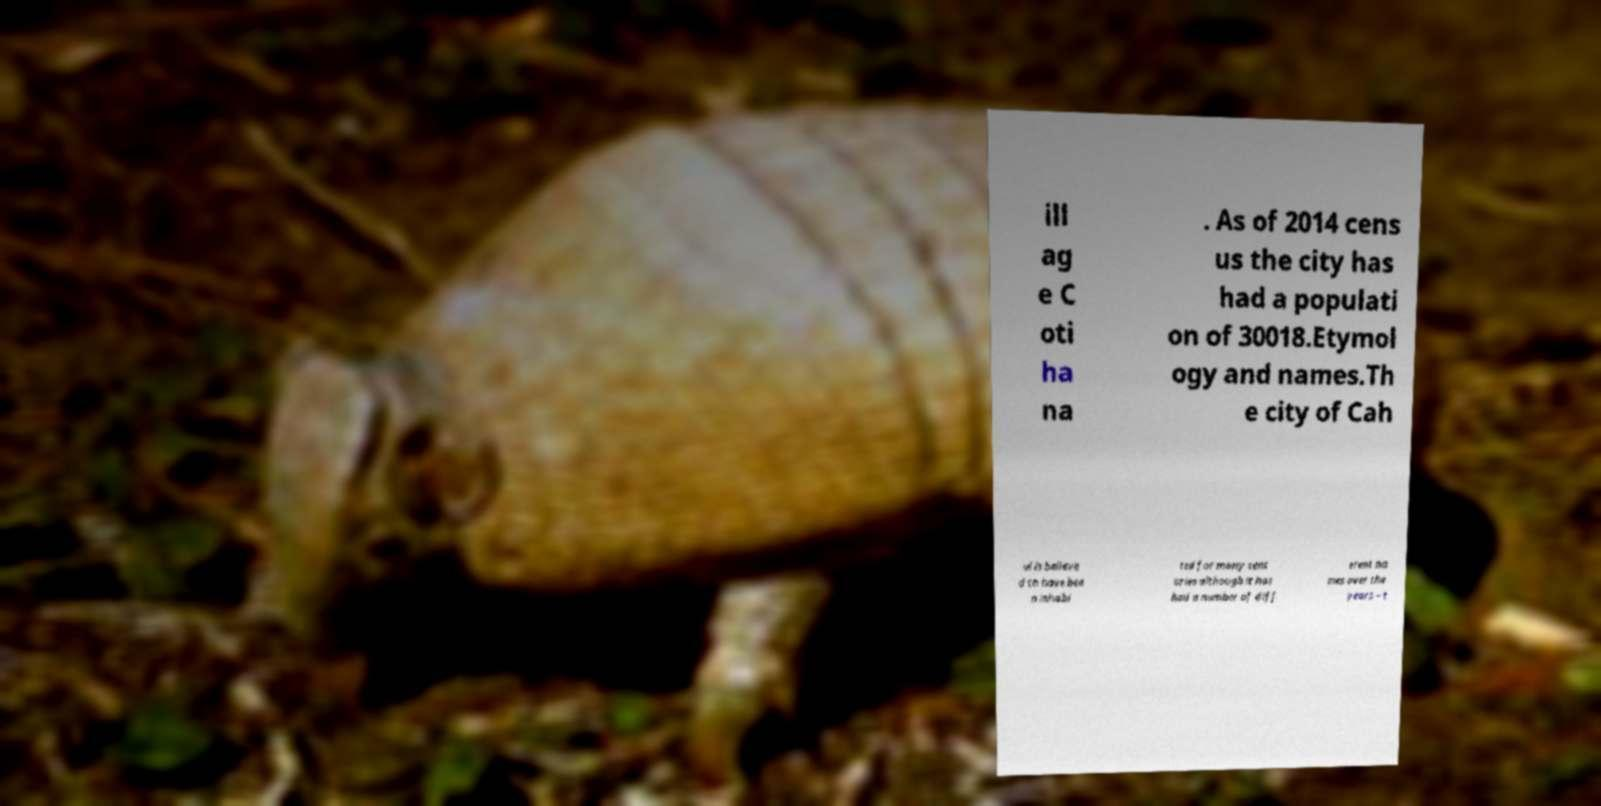Please read and relay the text visible in this image. What does it say? ill ag e C oti ha na . As of 2014 cens us the city has had a populati on of 30018.Etymol ogy and names.Th e city of Cah ul is believe d to have bee n inhabi ted for many cent uries although it has had a number of diff erent na mes over the years – t 